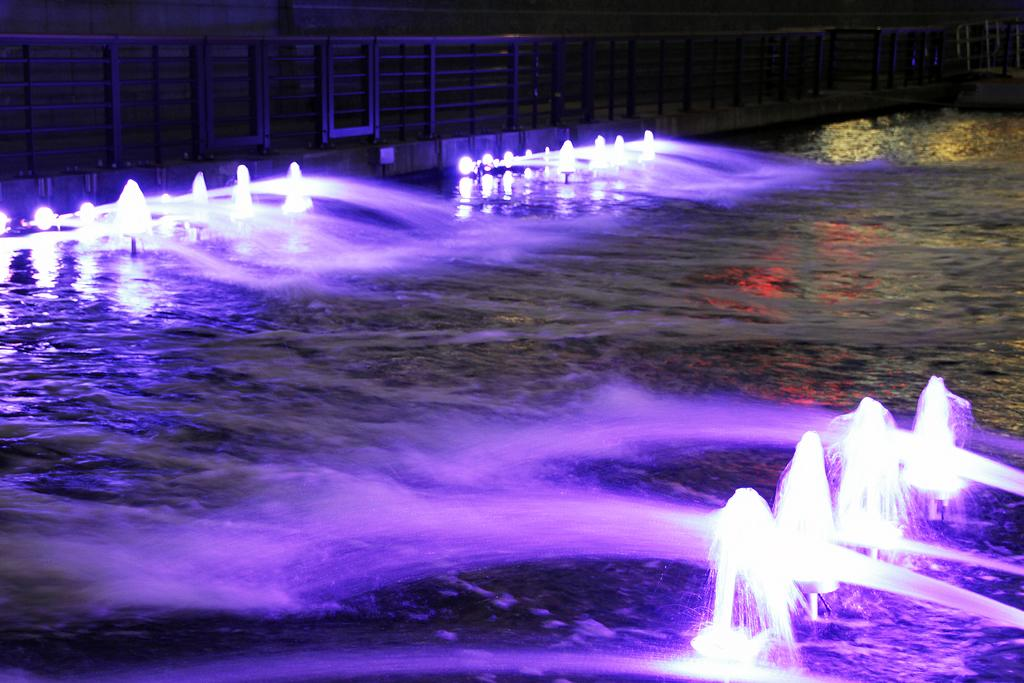What is in the water in the image? There are fountains in the water. What is located behind the fountains? There is a railing behind the fountains. What can be seen in the background of the image? There is a wall visible in the background. How many teeth can be seen in the fountains in the image? There are no teeth present in the fountains or the image. What color is the elbow of the person behind the railing in the image? There is no person or elbow visible in the image. 